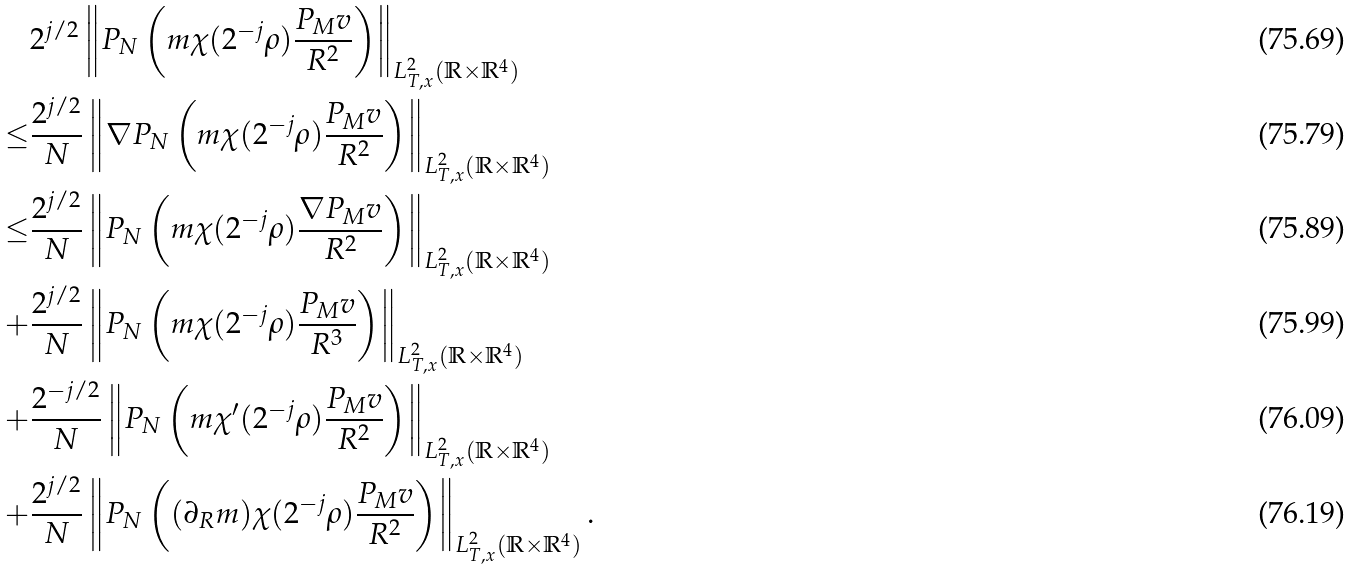<formula> <loc_0><loc_0><loc_500><loc_500>& 2 ^ { j / 2 } \left \| P _ { N } \left ( m \chi ( 2 ^ { - j } \rho ) \frac { P _ { M } v } { R ^ { 2 } } \right ) \right \| _ { L _ { T , x } ^ { 2 } ( \mathbb { R } \times \mathbb { R } ^ { 4 } ) } \\ \leq & \frac { 2 ^ { j / 2 } } { N } \left \| \nabla P _ { N } \left ( m \chi ( 2 ^ { - j } \rho ) \frac { P _ { M } v } { R ^ { 2 } } \right ) \right \| _ { L _ { T , x } ^ { 2 } ( \mathbb { R } \times \mathbb { R } ^ { 4 } ) } \\ \leq & \frac { 2 ^ { j / 2 } } { N } \left \| P _ { N } \left ( m \chi ( 2 ^ { - j } \rho ) \frac { \nabla P _ { M } v } { R ^ { 2 } } \right ) \right \| _ { L _ { T , x } ^ { 2 } ( \mathbb { R } \times \mathbb { R } ^ { 4 } ) } \\ + & \frac { 2 ^ { j / 2 } } { N } \left \| P _ { N } \left ( m \chi ( 2 ^ { - j } \rho ) \frac { P _ { M } v } { R ^ { 3 } } \right ) \right \| _ { L _ { T , x } ^ { 2 } ( \mathbb { R } \times \mathbb { R } ^ { 4 } ) } \\ + & \frac { 2 ^ { - j / 2 } } { N } \left \| P _ { N } \left ( m \chi ^ { \prime } ( 2 ^ { - j } \rho ) \frac { P _ { M } v } { R ^ { 2 } } \right ) \right \| _ { L _ { T , x } ^ { 2 } ( \mathbb { R } \times \mathbb { R } ^ { 4 } ) } \\ + & \frac { 2 ^ { j / 2 } } { N } \left \| P _ { N } \left ( ( \partial _ { R } m ) \chi ( 2 ^ { - j } \rho ) \frac { P _ { M } v } { R ^ { 2 } } \right ) \right \| _ { L _ { T , x } ^ { 2 } ( \mathbb { R } \times \mathbb { R } ^ { 4 } ) } .</formula> 